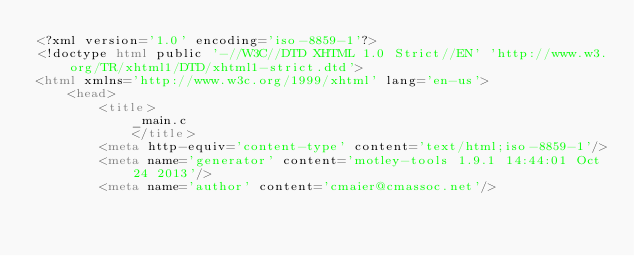Convert code to text. <code><loc_0><loc_0><loc_500><loc_500><_HTML_><?xml version='1.0' encoding='iso-8859-1'?>
<!doctype html public '-//W3C//DTD XHTML 1.0 Strict//EN' 'http://www.w3.org/TR/xhtml1/DTD/xhtml1-strict.dtd'>
<html xmlns='http://www.w3c.org/1999/xhtml' lang='en-us'>
	<head>
		<title>
			_main.c
			</title>
		<meta http-equiv='content-type' content='text/html;iso-8859-1'/>
		<meta name='generator' content='motley-tools 1.9.1 14:44:01 Oct 24 2013'/>
		<meta name='author' content='cmaier@cmassoc.net'/></code> 